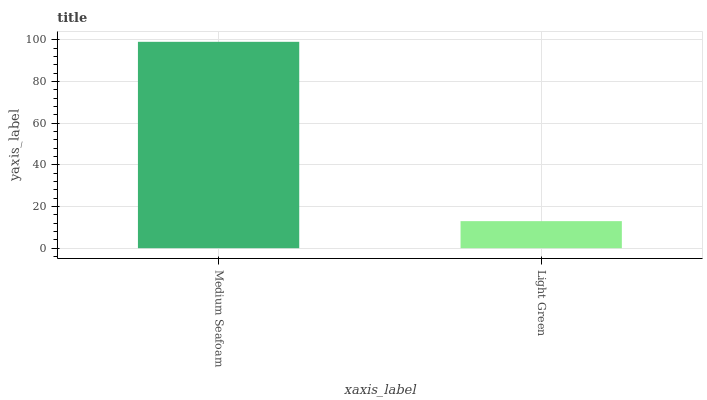Is Light Green the minimum?
Answer yes or no. Yes. Is Medium Seafoam the maximum?
Answer yes or no. Yes. Is Light Green the maximum?
Answer yes or no. No. Is Medium Seafoam greater than Light Green?
Answer yes or no. Yes. Is Light Green less than Medium Seafoam?
Answer yes or no. Yes. Is Light Green greater than Medium Seafoam?
Answer yes or no. No. Is Medium Seafoam less than Light Green?
Answer yes or no. No. Is Medium Seafoam the high median?
Answer yes or no. Yes. Is Light Green the low median?
Answer yes or no. Yes. Is Light Green the high median?
Answer yes or no. No. Is Medium Seafoam the low median?
Answer yes or no. No. 